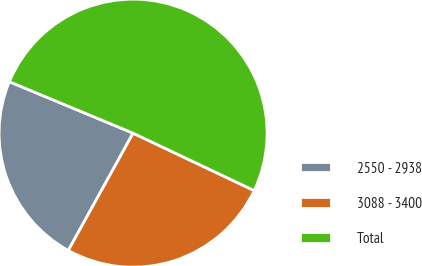Convert chart. <chart><loc_0><loc_0><loc_500><loc_500><pie_chart><fcel>2550 - 2938<fcel>3088 - 3400<fcel>Total<nl><fcel>23.24%<fcel>25.99%<fcel>50.77%<nl></chart> 